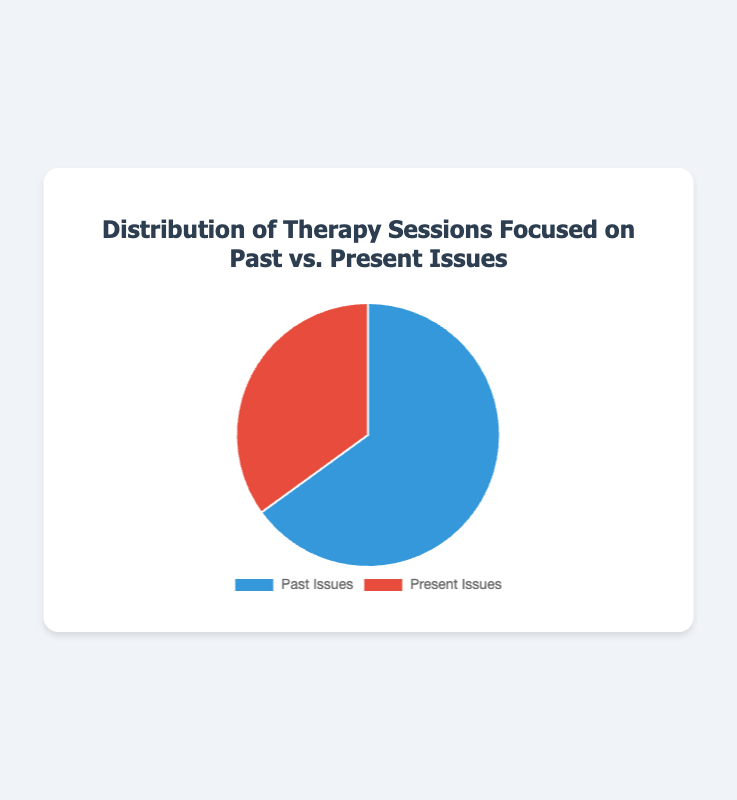What percentage of therapy sessions is focused on past issues? The pie chart shows the distribution of therapy sessions, with 65% allocated to past issues.
Answer: 65% What percentage of therapy sessions is focused on present issues? The pie chart indicates that 35% of therapy sessions are focused on present issues.
Answer: 35% How much more focus is there on past issues compared to present issues? To find out how much more focus there is on past issues compared to present issues, subtract the percentage of sessions focused on present issues (35%) from those focused on past issues (65%): 65% - 35% = 30%.
Answer: 30% If there were 100 therapy sessions last month, how many were focused on past issues? To find the number of sessions focused on past issues, calculate 65% of 100: (65/100) * 100 = 65 sessions.
Answer: 65 sessions If there were 200 therapy sessions in total, how many were focused on present issues? To find the number of sessions focused on present issues, calculate 35% of 200: (35/100) * 200 = 70 sessions.
Answer: 70 sessions What is the ratio of sessions focused on past issues to those focused on present issues? The ratio can be found by dividing the percentage of sessions focused on past issues (65) by the percentage focused on present issues (35): 65/35 simplifies to approximately 1.86 (or 65:35).
Answer: 1.86 Which issue, past or present, is less focused on in therapy sessions? The pie chart shows that 35% of sessions are focused on present issues, which is less than the 65% focused on past issues.
Answer: Present issues What is the sum of the percentages for both past and present issues? Adding the percentages for past issues (65%) and present issues (35%) gives: 65% + 35% = 100%.
Answer: 100% By how many percentage points is the focus on past issues greater than on present issues? Subtract the percentage of present issues (35%) from the percentage of past issues (65%): 65% - 35% = 30%.
Answer: 30% What colors represent past issues and present issues in the pie chart? The pie chart uses blue to represent past issues and red to represent present issues, according to their background colors.
Answer: Blue and red 